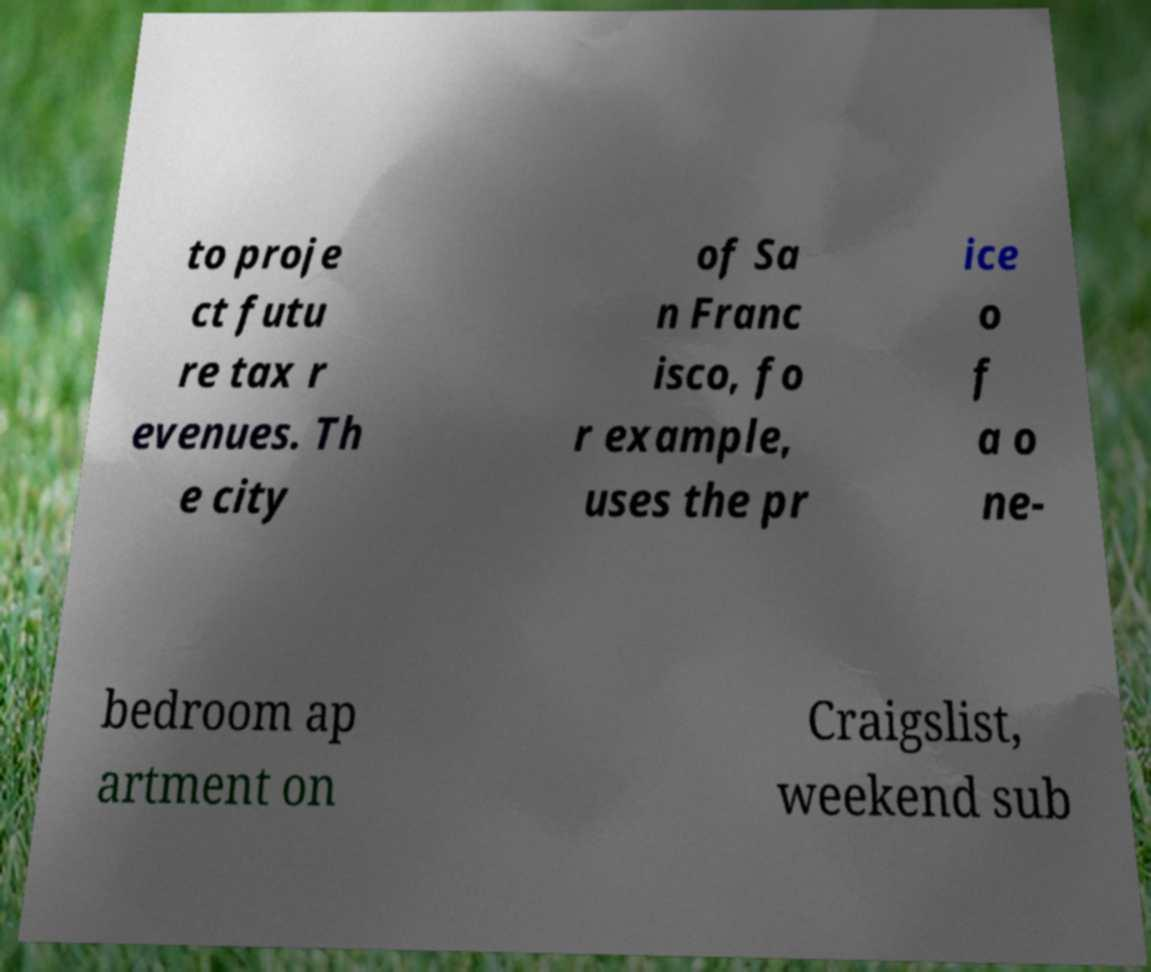Can you accurately transcribe the text from the provided image for me? to proje ct futu re tax r evenues. Th e city of Sa n Franc isco, fo r example, uses the pr ice o f a o ne- bedroom ap artment on Craigslist, weekend sub 